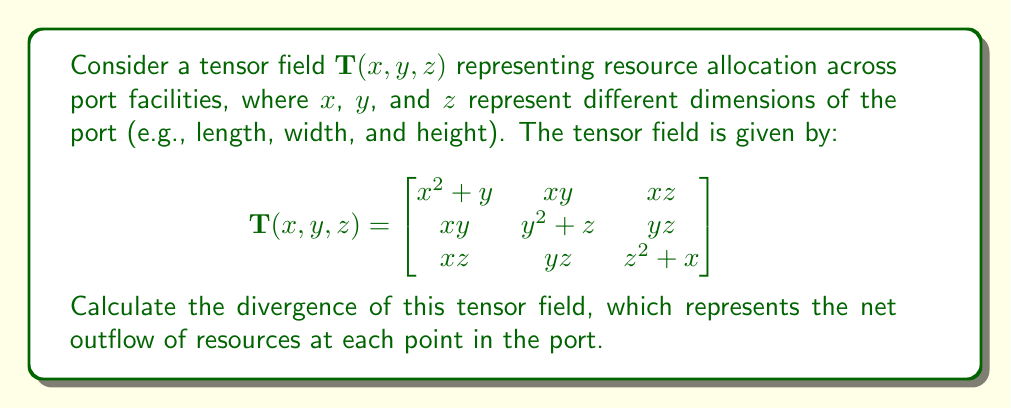What is the answer to this math problem? To calculate the divergence of a tensor field, we need to sum the partial derivatives of the diagonal elements with respect to their corresponding variables. For a 3D tensor field, the divergence is given by:

$$\text{div}(\mathbf{T}) = \frac{\partial T_{xx}}{\partial x} + \frac{\partial T_{yy}}{\partial y} + \frac{\partial T_{zz}}{\partial z}$$

Let's calculate each term:

1. $\frac{\partial T_{xx}}{\partial x}$:
   $T_{xx} = x^2 + y$
   $\frac{\partial T_{xx}}{\partial x} = 2x$

2. $\frac{\partial T_{yy}}{\partial y}$:
   $T_{yy} = y^2 + z$
   $\frac{\partial T_{yy}}{\partial y} = 2y$

3. $\frac{\partial T_{zz}}{\partial z}$:
   $T_{zz} = z^2 + x$
   $\frac{\partial T_{zz}}{\partial z} = 2z$

Now, we sum these partial derivatives:

$$\text{div}(\mathbf{T}) = 2x + 2y + 2z$$

This result represents the net outflow of resources at each point $(x,y,z)$ in the port facility.
Answer: $2x + 2y + 2z$ 